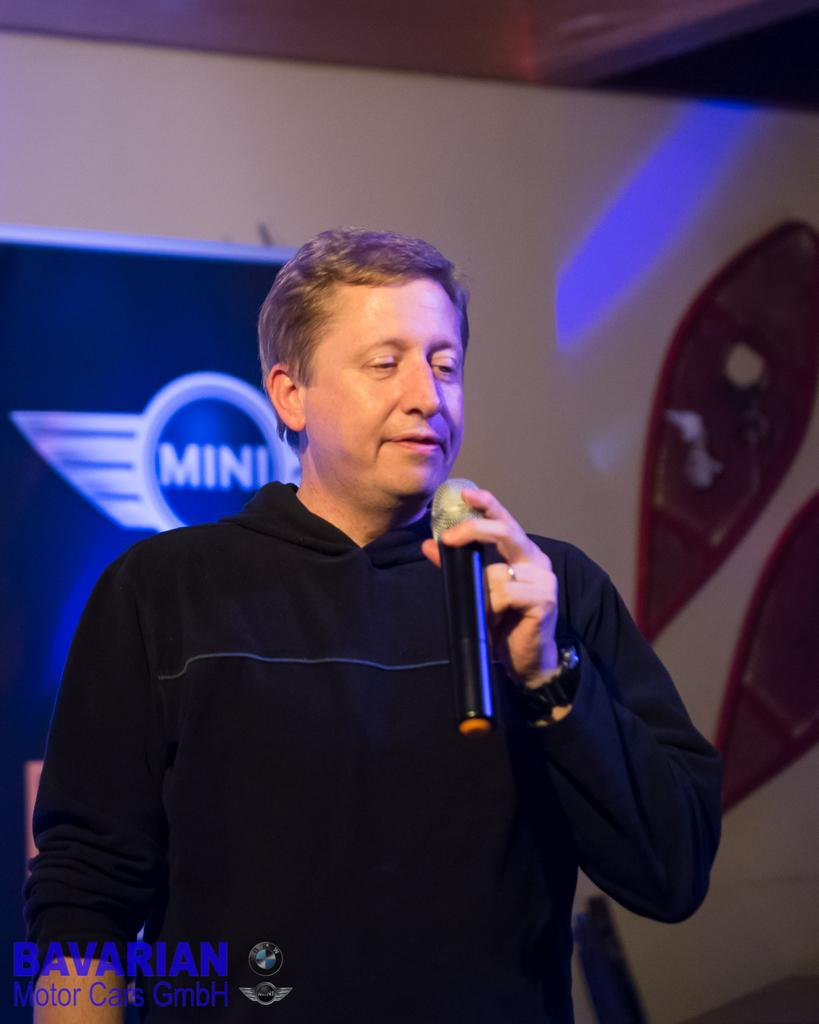What is the main subject of the image? There is a man in the image. What is the man doing in the image? The man is standing and holding a mic in his hands. What can be seen in the background of the image? There is a poster and a wall in the background of the image. What type of fan is visible in the image? There is no fan present in the image. What kind of print can be seen on the man's shirt in the image? The man's shirt is not visible in the image, so it is not possible to determine if there is any print on it. 